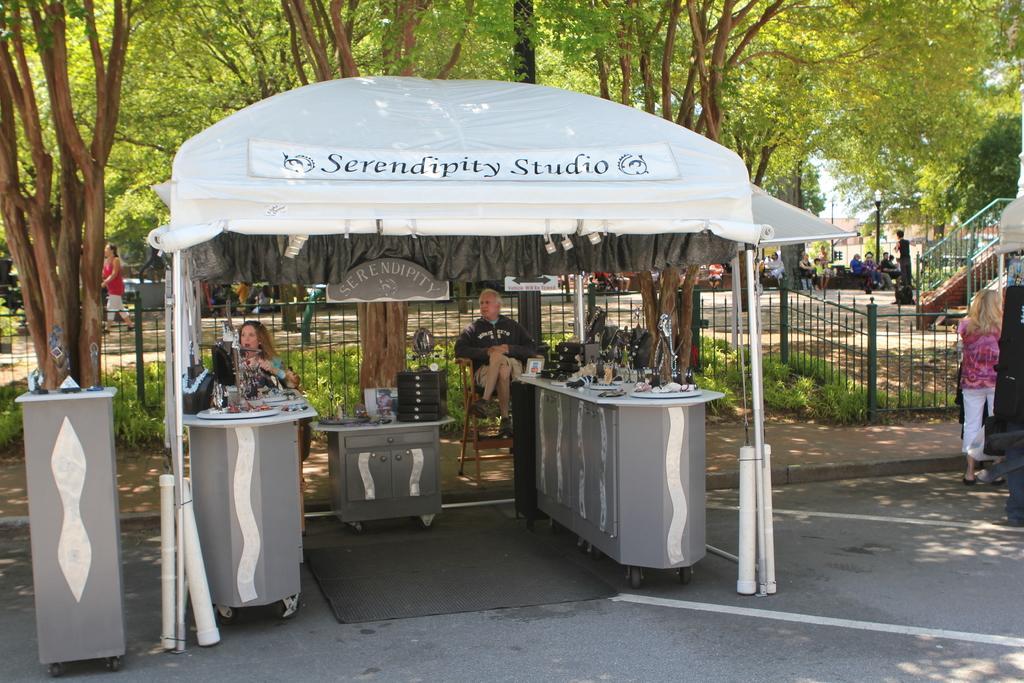Could you give a brief overview of what you see in this image? In this image we can able see a tent, there are four tables, on top of those tables we can see come objects, and there is a person sitting on the chair, we can see few trees. There is a fencing, behind that we can see some people, and there is a staircase. 